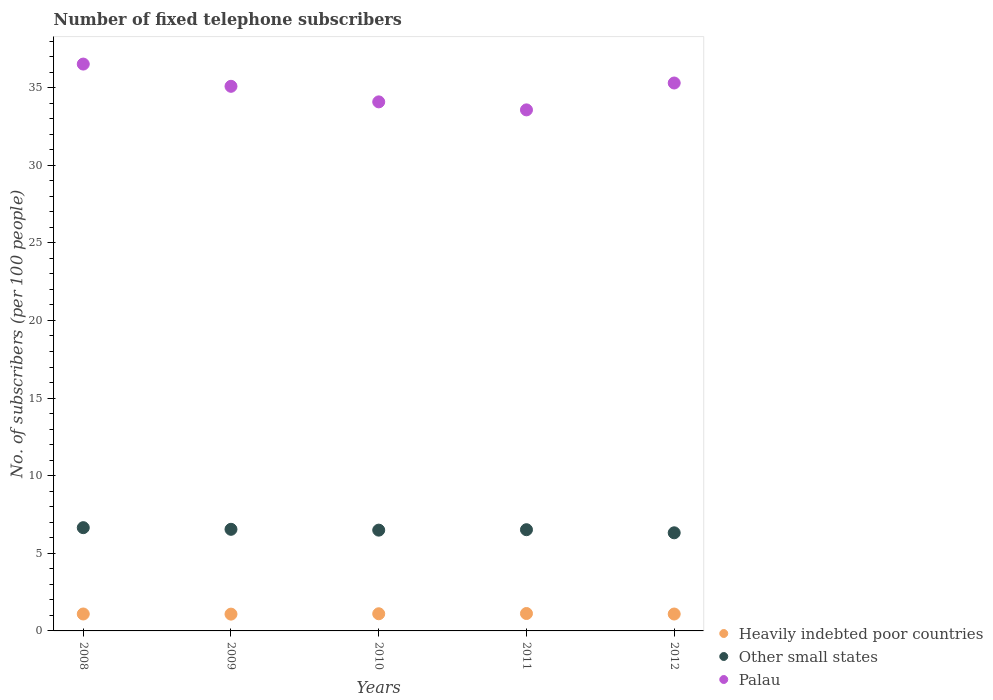Is the number of dotlines equal to the number of legend labels?
Your answer should be compact. Yes. What is the number of fixed telephone subscribers in Heavily indebted poor countries in 2008?
Offer a terse response. 1.09. Across all years, what is the maximum number of fixed telephone subscribers in Palau?
Provide a succinct answer. 36.51. Across all years, what is the minimum number of fixed telephone subscribers in Heavily indebted poor countries?
Make the answer very short. 1.08. In which year was the number of fixed telephone subscribers in Other small states maximum?
Provide a succinct answer. 2008. What is the total number of fixed telephone subscribers in Palau in the graph?
Your response must be concise. 174.53. What is the difference between the number of fixed telephone subscribers in Heavily indebted poor countries in 2011 and that in 2012?
Provide a short and direct response. 0.03. What is the difference between the number of fixed telephone subscribers in Other small states in 2010 and the number of fixed telephone subscribers in Palau in 2012?
Your response must be concise. -28.8. What is the average number of fixed telephone subscribers in Palau per year?
Ensure brevity in your answer.  34.91. In the year 2012, what is the difference between the number of fixed telephone subscribers in Palau and number of fixed telephone subscribers in Heavily indebted poor countries?
Your answer should be very brief. 34.21. What is the ratio of the number of fixed telephone subscribers in Palau in 2008 to that in 2011?
Ensure brevity in your answer.  1.09. Is the number of fixed telephone subscribers in Palau in 2010 less than that in 2011?
Ensure brevity in your answer.  No. Is the difference between the number of fixed telephone subscribers in Palau in 2008 and 2011 greater than the difference between the number of fixed telephone subscribers in Heavily indebted poor countries in 2008 and 2011?
Offer a terse response. Yes. What is the difference between the highest and the second highest number of fixed telephone subscribers in Heavily indebted poor countries?
Keep it short and to the point. 0.02. What is the difference between the highest and the lowest number of fixed telephone subscribers in Other small states?
Your response must be concise. 0.33. In how many years, is the number of fixed telephone subscribers in Palau greater than the average number of fixed telephone subscribers in Palau taken over all years?
Your answer should be very brief. 3. Does the number of fixed telephone subscribers in Heavily indebted poor countries monotonically increase over the years?
Provide a succinct answer. No. Is the number of fixed telephone subscribers in Other small states strictly less than the number of fixed telephone subscribers in Heavily indebted poor countries over the years?
Give a very brief answer. No. How many dotlines are there?
Your response must be concise. 3. How many years are there in the graph?
Make the answer very short. 5. Are the values on the major ticks of Y-axis written in scientific E-notation?
Your answer should be compact. No. Does the graph contain grids?
Give a very brief answer. No. What is the title of the graph?
Make the answer very short. Number of fixed telephone subscribers. What is the label or title of the X-axis?
Offer a terse response. Years. What is the label or title of the Y-axis?
Give a very brief answer. No. of subscribers (per 100 people). What is the No. of subscribers (per 100 people) in Heavily indebted poor countries in 2008?
Provide a short and direct response. 1.09. What is the No. of subscribers (per 100 people) in Other small states in 2008?
Offer a terse response. 6.65. What is the No. of subscribers (per 100 people) of Palau in 2008?
Provide a succinct answer. 36.51. What is the No. of subscribers (per 100 people) of Heavily indebted poor countries in 2009?
Your answer should be very brief. 1.08. What is the No. of subscribers (per 100 people) in Other small states in 2009?
Your response must be concise. 6.55. What is the No. of subscribers (per 100 people) in Palau in 2009?
Ensure brevity in your answer.  35.08. What is the No. of subscribers (per 100 people) of Heavily indebted poor countries in 2010?
Ensure brevity in your answer.  1.11. What is the No. of subscribers (per 100 people) of Other small states in 2010?
Offer a very short reply. 6.49. What is the No. of subscribers (per 100 people) in Palau in 2010?
Offer a very short reply. 34.08. What is the No. of subscribers (per 100 people) in Heavily indebted poor countries in 2011?
Ensure brevity in your answer.  1.12. What is the No. of subscribers (per 100 people) of Other small states in 2011?
Provide a short and direct response. 6.52. What is the No. of subscribers (per 100 people) of Palau in 2011?
Provide a short and direct response. 33.56. What is the No. of subscribers (per 100 people) of Heavily indebted poor countries in 2012?
Your answer should be compact. 1.09. What is the No. of subscribers (per 100 people) in Other small states in 2012?
Offer a terse response. 6.32. What is the No. of subscribers (per 100 people) in Palau in 2012?
Your response must be concise. 35.29. Across all years, what is the maximum No. of subscribers (per 100 people) of Heavily indebted poor countries?
Your answer should be very brief. 1.12. Across all years, what is the maximum No. of subscribers (per 100 people) of Other small states?
Your answer should be compact. 6.65. Across all years, what is the maximum No. of subscribers (per 100 people) in Palau?
Make the answer very short. 36.51. Across all years, what is the minimum No. of subscribers (per 100 people) of Heavily indebted poor countries?
Your answer should be compact. 1.08. Across all years, what is the minimum No. of subscribers (per 100 people) of Other small states?
Your response must be concise. 6.32. Across all years, what is the minimum No. of subscribers (per 100 people) of Palau?
Your answer should be compact. 33.56. What is the total No. of subscribers (per 100 people) of Heavily indebted poor countries in the graph?
Keep it short and to the point. 5.49. What is the total No. of subscribers (per 100 people) of Other small states in the graph?
Keep it short and to the point. 32.53. What is the total No. of subscribers (per 100 people) in Palau in the graph?
Make the answer very short. 174.53. What is the difference between the No. of subscribers (per 100 people) in Heavily indebted poor countries in 2008 and that in 2009?
Keep it short and to the point. 0.01. What is the difference between the No. of subscribers (per 100 people) of Other small states in 2008 and that in 2009?
Keep it short and to the point. 0.11. What is the difference between the No. of subscribers (per 100 people) in Palau in 2008 and that in 2009?
Your answer should be compact. 1.43. What is the difference between the No. of subscribers (per 100 people) in Heavily indebted poor countries in 2008 and that in 2010?
Keep it short and to the point. -0.01. What is the difference between the No. of subscribers (per 100 people) of Other small states in 2008 and that in 2010?
Your answer should be very brief. 0.16. What is the difference between the No. of subscribers (per 100 people) of Palau in 2008 and that in 2010?
Give a very brief answer. 2.43. What is the difference between the No. of subscribers (per 100 people) in Heavily indebted poor countries in 2008 and that in 2011?
Your answer should be very brief. -0.03. What is the difference between the No. of subscribers (per 100 people) in Other small states in 2008 and that in 2011?
Make the answer very short. 0.13. What is the difference between the No. of subscribers (per 100 people) in Palau in 2008 and that in 2011?
Keep it short and to the point. 2.95. What is the difference between the No. of subscribers (per 100 people) of Heavily indebted poor countries in 2008 and that in 2012?
Offer a very short reply. 0. What is the difference between the No. of subscribers (per 100 people) of Other small states in 2008 and that in 2012?
Your answer should be very brief. 0.33. What is the difference between the No. of subscribers (per 100 people) in Palau in 2008 and that in 2012?
Make the answer very short. 1.22. What is the difference between the No. of subscribers (per 100 people) of Heavily indebted poor countries in 2009 and that in 2010?
Your response must be concise. -0.02. What is the difference between the No. of subscribers (per 100 people) in Other small states in 2009 and that in 2010?
Your response must be concise. 0.05. What is the difference between the No. of subscribers (per 100 people) of Heavily indebted poor countries in 2009 and that in 2011?
Provide a succinct answer. -0.04. What is the difference between the No. of subscribers (per 100 people) of Other small states in 2009 and that in 2011?
Provide a short and direct response. 0.03. What is the difference between the No. of subscribers (per 100 people) in Palau in 2009 and that in 2011?
Keep it short and to the point. 1.52. What is the difference between the No. of subscribers (per 100 people) of Heavily indebted poor countries in 2009 and that in 2012?
Make the answer very short. -0.01. What is the difference between the No. of subscribers (per 100 people) of Other small states in 2009 and that in 2012?
Your answer should be compact. 0.23. What is the difference between the No. of subscribers (per 100 people) of Palau in 2009 and that in 2012?
Your answer should be compact. -0.21. What is the difference between the No. of subscribers (per 100 people) in Heavily indebted poor countries in 2010 and that in 2011?
Ensure brevity in your answer.  -0.02. What is the difference between the No. of subscribers (per 100 people) in Other small states in 2010 and that in 2011?
Give a very brief answer. -0.03. What is the difference between the No. of subscribers (per 100 people) in Palau in 2010 and that in 2011?
Offer a terse response. 0.52. What is the difference between the No. of subscribers (per 100 people) in Heavily indebted poor countries in 2010 and that in 2012?
Ensure brevity in your answer.  0.02. What is the difference between the No. of subscribers (per 100 people) in Other small states in 2010 and that in 2012?
Ensure brevity in your answer.  0.17. What is the difference between the No. of subscribers (per 100 people) of Palau in 2010 and that in 2012?
Keep it short and to the point. -1.22. What is the difference between the No. of subscribers (per 100 people) in Heavily indebted poor countries in 2011 and that in 2012?
Keep it short and to the point. 0.03. What is the difference between the No. of subscribers (per 100 people) in Other small states in 2011 and that in 2012?
Ensure brevity in your answer.  0.2. What is the difference between the No. of subscribers (per 100 people) in Palau in 2011 and that in 2012?
Keep it short and to the point. -1.73. What is the difference between the No. of subscribers (per 100 people) in Heavily indebted poor countries in 2008 and the No. of subscribers (per 100 people) in Other small states in 2009?
Your answer should be very brief. -5.45. What is the difference between the No. of subscribers (per 100 people) in Heavily indebted poor countries in 2008 and the No. of subscribers (per 100 people) in Palau in 2009?
Provide a succinct answer. -33.99. What is the difference between the No. of subscribers (per 100 people) in Other small states in 2008 and the No. of subscribers (per 100 people) in Palau in 2009?
Offer a terse response. -28.43. What is the difference between the No. of subscribers (per 100 people) in Heavily indebted poor countries in 2008 and the No. of subscribers (per 100 people) in Other small states in 2010?
Provide a succinct answer. -5.4. What is the difference between the No. of subscribers (per 100 people) of Heavily indebted poor countries in 2008 and the No. of subscribers (per 100 people) of Palau in 2010?
Offer a very short reply. -32.99. What is the difference between the No. of subscribers (per 100 people) of Other small states in 2008 and the No. of subscribers (per 100 people) of Palau in 2010?
Provide a succinct answer. -27.43. What is the difference between the No. of subscribers (per 100 people) of Heavily indebted poor countries in 2008 and the No. of subscribers (per 100 people) of Other small states in 2011?
Your answer should be compact. -5.43. What is the difference between the No. of subscribers (per 100 people) of Heavily indebted poor countries in 2008 and the No. of subscribers (per 100 people) of Palau in 2011?
Keep it short and to the point. -32.47. What is the difference between the No. of subscribers (per 100 people) of Other small states in 2008 and the No. of subscribers (per 100 people) of Palau in 2011?
Provide a short and direct response. -26.91. What is the difference between the No. of subscribers (per 100 people) of Heavily indebted poor countries in 2008 and the No. of subscribers (per 100 people) of Other small states in 2012?
Your answer should be very brief. -5.23. What is the difference between the No. of subscribers (per 100 people) of Heavily indebted poor countries in 2008 and the No. of subscribers (per 100 people) of Palau in 2012?
Provide a succinct answer. -34.2. What is the difference between the No. of subscribers (per 100 people) in Other small states in 2008 and the No. of subscribers (per 100 people) in Palau in 2012?
Provide a succinct answer. -28.64. What is the difference between the No. of subscribers (per 100 people) of Heavily indebted poor countries in 2009 and the No. of subscribers (per 100 people) of Other small states in 2010?
Make the answer very short. -5.41. What is the difference between the No. of subscribers (per 100 people) of Heavily indebted poor countries in 2009 and the No. of subscribers (per 100 people) of Palau in 2010?
Provide a short and direct response. -33. What is the difference between the No. of subscribers (per 100 people) of Other small states in 2009 and the No. of subscribers (per 100 people) of Palau in 2010?
Provide a short and direct response. -27.53. What is the difference between the No. of subscribers (per 100 people) in Heavily indebted poor countries in 2009 and the No. of subscribers (per 100 people) in Other small states in 2011?
Offer a terse response. -5.44. What is the difference between the No. of subscribers (per 100 people) of Heavily indebted poor countries in 2009 and the No. of subscribers (per 100 people) of Palau in 2011?
Provide a short and direct response. -32.48. What is the difference between the No. of subscribers (per 100 people) in Other small states in 2009 and the No. of subscribers (per 100 people) in Palau in 2011?
Offer a very short reply. -27.02. What is the difference between the No. of subscribers (per 100 people) in Heavily indebted poor countries in 2009 and the No. of subscribers (per 100 people) in Other small states in 2012?
Make the answer very short. -5.24. What is the difference between the No. of subscribers (per 100 people) of Heavily indebted poor countries in 2009 and the No. of subscribers (per 100 people) of Palau in 2012?
Your answer should be compact. -34.21. What is the difference between the No. of subscribers (per 100 people) in Other small states in 2009 and the No. of subscribers (per 100 people) in Palau in 2012?
Give a very brief answer. -28.75. What is the difference between the No. of subscribers (per 100 people) of Heavily indebted poor countries in 2010 and the No. of subscribers (per 100 people) of Other small states in 2011?
Provide a succinct answer. -5.41. What is the difference between the No. of subscribers (per 100 people) of Heavily indebted poor countries in 2010 and the No. of subscribers (per 100 people) of Palau in 2011?
Provide a short and direct response. -32.46. What is the difference between the No. of subscribers (per 100 people) in Other small states in 2010 and the No. of subscribers (per 100 people) in Palau in 2011?
Provide a succinct answer. -27.07. What is the difference between the No. of subscribers (per 100 people) of Heavily indebted poor countries in 2010 and the No. of subscribers (per 100 people) of Other small states in 2012?
Ensure brevity in your answer.  -5.21. What is the difference between the No. of subscribers (per 100 people) of Heavily indebted poor countries in 2010 and the No. of subscribers (per 100 people) of Palau in 2012?
Give a very brief answer. -34.19. What is the difference between the No. of subscribers (per 100 people) of Other small states in 2010 and the No. of subscribers (per 100 people) of Palau in 2012?
Your response must be concise. -28.8. What is the difference between the No. of subscribers (per 100 people) in Heavily indebted poor countries in 2011 and the No. of subscribers (per 100 people) in Other small states in 2012?
Your answer should be compact. -5.2. What is the difference between the No. of subscribers (per 100 people) in Heavily indebted poor countries in 2011 and the No. of subscribers (per 100 people) in Palau in 2012?
Ensure brevity in your answer.  -34.17. What is the difference between the No. of subscribers (per 100 people) in Other small states in 2011 and the No. of subscribers (per 100 people) in Palau in 2012?
Ensure brevity in your answer.  -28.77. What is the average No. of subscribers (per 100 people) in Heavily indebted poor countries per year?
Make the answer very short. 1.1. What is the average No. of subscribers (per 100 people) of Other small states per year?
Offer a very short reply. 6.51. What is the average No. of subscribers (per 100 people) in Palau per year?
Offer a terse response. 34.91. In the year 2008, what is the difference between the No. of subscribers (per 100 people) of Heavily indebted poor countries and No. of subscribers (per 100 people) of Other small states?
Offer a terse response. -5.56. In the year 2008, what is the difference between the No. of subscribers (per 100 people) in Heavily indebted poor countries and No. of subscribers (per 100 people) in Palau?
Provide a succinct answer. -35.42. In the year 2008, what is the difference between the No. of subscribers (per 100 people) in Other small states and No. of subscribers (per 100 people) in Palau?
Keep it short and to the point. -29.86. In the year 2009, what is the difference between the No. of subscribers (per 100 people) in Heavily indebted poor countries and No. of subscribers (per 100 people) in Other small states?
Your answer should be compact. -5.46. In the year 2009, what is the difference between the No. of subscribers (per 100 people) of Heavily indebted poor countries and No. of subscribers (per 100 people) of Palau?
Offer a terse response. -34. In the year 2009, what is the difference between the No. of subscribers (per 100 people) of Other small states and No. of subscribers (per 100 people) of Palau?
Keep it short and to the point. -28.54. In the year 2010, what is the difference between the No. of subscribers (per 100 people) of Heavily indebted poor countries and No. of subscribers (per 100 people) of Other small states?
Provide a short and direct response. -5.39. In the year 2010, what is the difference between the No. of subscribers (per 100 people) in Heavily indebted poor countries and No. of subscribers (per 100 people) in Palau?
Offer a terse response. -32.97. In the year 2010, what is the difference between the No. of subscribers (per 100 people) of Other small states and No. of subscribers (per 100 people) of Palau?
Provide a succinct answer. -27.59. In the year 2011, what is the difference between the No. of subscribers (per 100 people) in Heavily indebted poor countries and No. of subscribers (per 100 people) in Other small states?
Your response must be concise. -5.4. In the year 2011, what is the difference between the No. of subscribers (per 100 people) of Heavily indebted poor countries and No. of subscribers (per 100 people) of Palau?
Your answer should be compact. -32.44. In the year 2011, what is the difference between the No. of subscribers (per 100 people) of Other small states and No. of subscribers (per 100 people) of Palau?
Make the answer very short. -27.04. In the year 2012, what is the difference between the No. of subscribers (per 100 people) of Heavily indebted poor countries and No. of subscribers (per 100 people) of Other small states?
Give a very brief answer. -5.23. In the year 2012, what is the difference between the No. of subscribers (per 100 people) in Heavily indebted poor countries and No. of subscribers (per 100 people) in Palau?
Your response must be concise. -34.21. In the year 2012, what is the difference between the No. of subscribers (per 100 people) of Other small states and No. of subscribers (per 100 people) of Palau?
Keep it short and to the point. -28.97. What is the ratio of the No. of subscribers (per 100 people) of Heavily indebted poor countries in 2008 to that in 2009?
Your answer should be very brief. 1.01. What is the ratio of the No. of subscribers (per 100 people) of Other small states in 2008 to that in 2009?
Make the answer very short. 1.02. What is the ratio of the No. of subscribers (per 100 people) of Palau in 2008 to that in 2009?
Keep it short and to the point. 1.04. What is the ratio of the No. of subscribers (per 100 people) in Heavily indebted poor countries in 2008 to that in 2010?
Make the answer very short. 0.99. What is the ratio of the No. of subscribers (per 100 people) of Other small states in 2008 to that in 2010?
Ensure brevity in your answer.  1.02. What is the ratio of the No. of subscribers (per 100 people) in Palau in 2008 to that in 2010?
Keep it short and to the point. 1.07. What is the ratio of the No. of subscribers (per 100 people) of Heavily indebted poor countries in 2008 to that in 2011?
Your response must be concise. 0.97. What is the ratio of the No. of subscribers (per 100 people) in Other small states in 2008 to that in 2011?
Provide a succinct answer. 1.02. What is the ratio of the No. of subscribers (per 100 people) in Palau in 2008 to that in 2011?
Make the answer very short. 1.09. What is the ratio of the No. of subscribers (per 100 people) of Other small states in 2008 to that in 2012?
Keep it short and to the point. 1.05. What is the ratio of the No. of subscribers (per 100 people) in Palau in 2008 to that in 2012?
Provide a short and direct response. 1.03. What is the ratio of the No. of subscribers (per 100 people) in Heavily indebted poor countries in 2009 to that in 2010?
Offer a very short reply. 0.98. What is the ratio of the No. of subscribers (per 100 people) in Other small states in 2009 to that in 2010?
Offer a very short reply. 1.01. What is the ratio of the No. of subscribers (per 100 people) of Palau in 2009 to that in 2010?
Your response must be concise. 1.03. What is the ratio of the No. of subscribers (per 100 people) in Heavily indebted poor countries in 2009 to that in 2011?
Provide a short and direct response. 0.96. What is the ratio of the No. of subscribers (per 100 people) in Other small states in 2009 to that in 2011?
Your answer should be very brief. 1. What is the ratio of the No. of subscribers (per 100 people) of Palau in 2009 to that in 2011?
Make the answer very short. 1.05. What is the ratio of the No. of subscribers (per 100 people) of Heavily indebted poor countries in 2009 to that in 2012?
Make the answer very short. 0.99. What is the ratio of the No. of subscribers (per 100 people) in Other small states in 2009 to that in 2012?
Offer a terse response. 1.04. What is the ratio of the No. of subscribers (per 100 people) of Heavily indebted poor countries in 2010 to that in 2011?
Give a very brief answer. 0.99. What is the ratio of the No. of subscribers (per 100 people) in Other small states in 2010 to that in 2011?
Give a very brief answer. 1. What is the ratio of the No. of subscribers (per 100 people) in Palau in 2010 to that in 2011?
Provide a short and direct response. 1.02. What is the ratio of the No. of subscribers (per 100 people) in Heavily indebted poor countries in 2010 to that in 2012?
Offer a terse response. 1.02. What is the ratio of the No. of subscribers (per 100 people) of Other small states in 2010 to that in 2012?
Offer a terse response. 1.03. What is the ratio of the No. of subscribers (per 100 people) in Palau in 2010 to that in 2012?
Provide a short and direct response. 0.97. What is the ratio of the No. of subscribers (per 100 people) of Heavily indebted poor countries in 2011 to that in 2012?
Provide a short and direct response. 1.03. What is the ratio of the No. of subscribers (per 100 people) of Other small states in 2011 to that in 2012?
Your answer should be very brief. 1.03. What is the ratio of the No. of subscribers (per 100 people) in Palau in 2011 to that in 2012?
Offer a very short reply. 0.95. What is the difference between the highest and the second highest No. of subscribers (per 100 people) of Heavily indebted poor countries?
Offer a very short reply. 0.02. What is the difference between the highest and the second highest No. of subscribers (per 100 people) of Other small states?
Your response must be concise. 0.11. What is the difference between the highest and the second highest No. of subscribers (per 100 people) of Palau?
Offer a terse response. 1.22. What is the difference between the highest and the lowest No. of subscribers (per 100 people) of Heavily indebted poor countries?
Make the answer very short. 0.04. What is the difference between the highest and the lowest No. of subscribers (per 100 people) of Other small states?
Your response must be concise. 0.33. What is the difference between the highest and the lowest No. of subscribers (per 100 people) in Palau?
Your answer should be very brief. 2.95. 